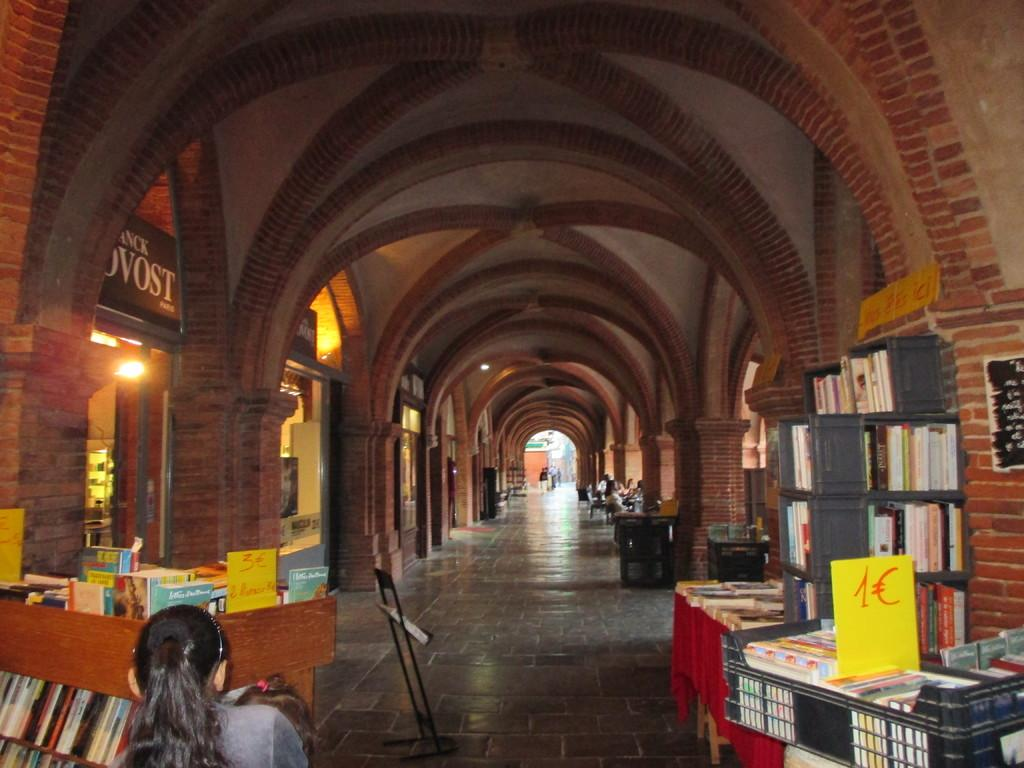<image>
Write a terse but informative summary of the picture. A building full of books, with an arched, brick ceiling, has yellow signs above the books, with their prices written in euros. 